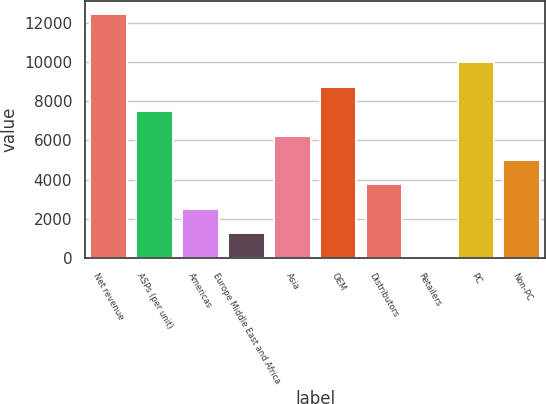<chart> <loc_0><loc_0><loc_500><loc_500><bar_chart><fcel>Net revenue<fcel>ASPs (per unit)<fcel>Americas<fcel>Europe Middle East and Africa<fcel>Asia<fcel>OEM<fcel>Distributors<fcel>Retailers<fcel>PC<fcel>Non-PC<nl><fcel>12478<fcel>7491.6<fcel>2505.2<fcel>1258.6<fcel>6245<fcel>8738.2<fcel>3751.8<fcel>12<fcel>9984.8<fcel>4998.4<nl></chart> 